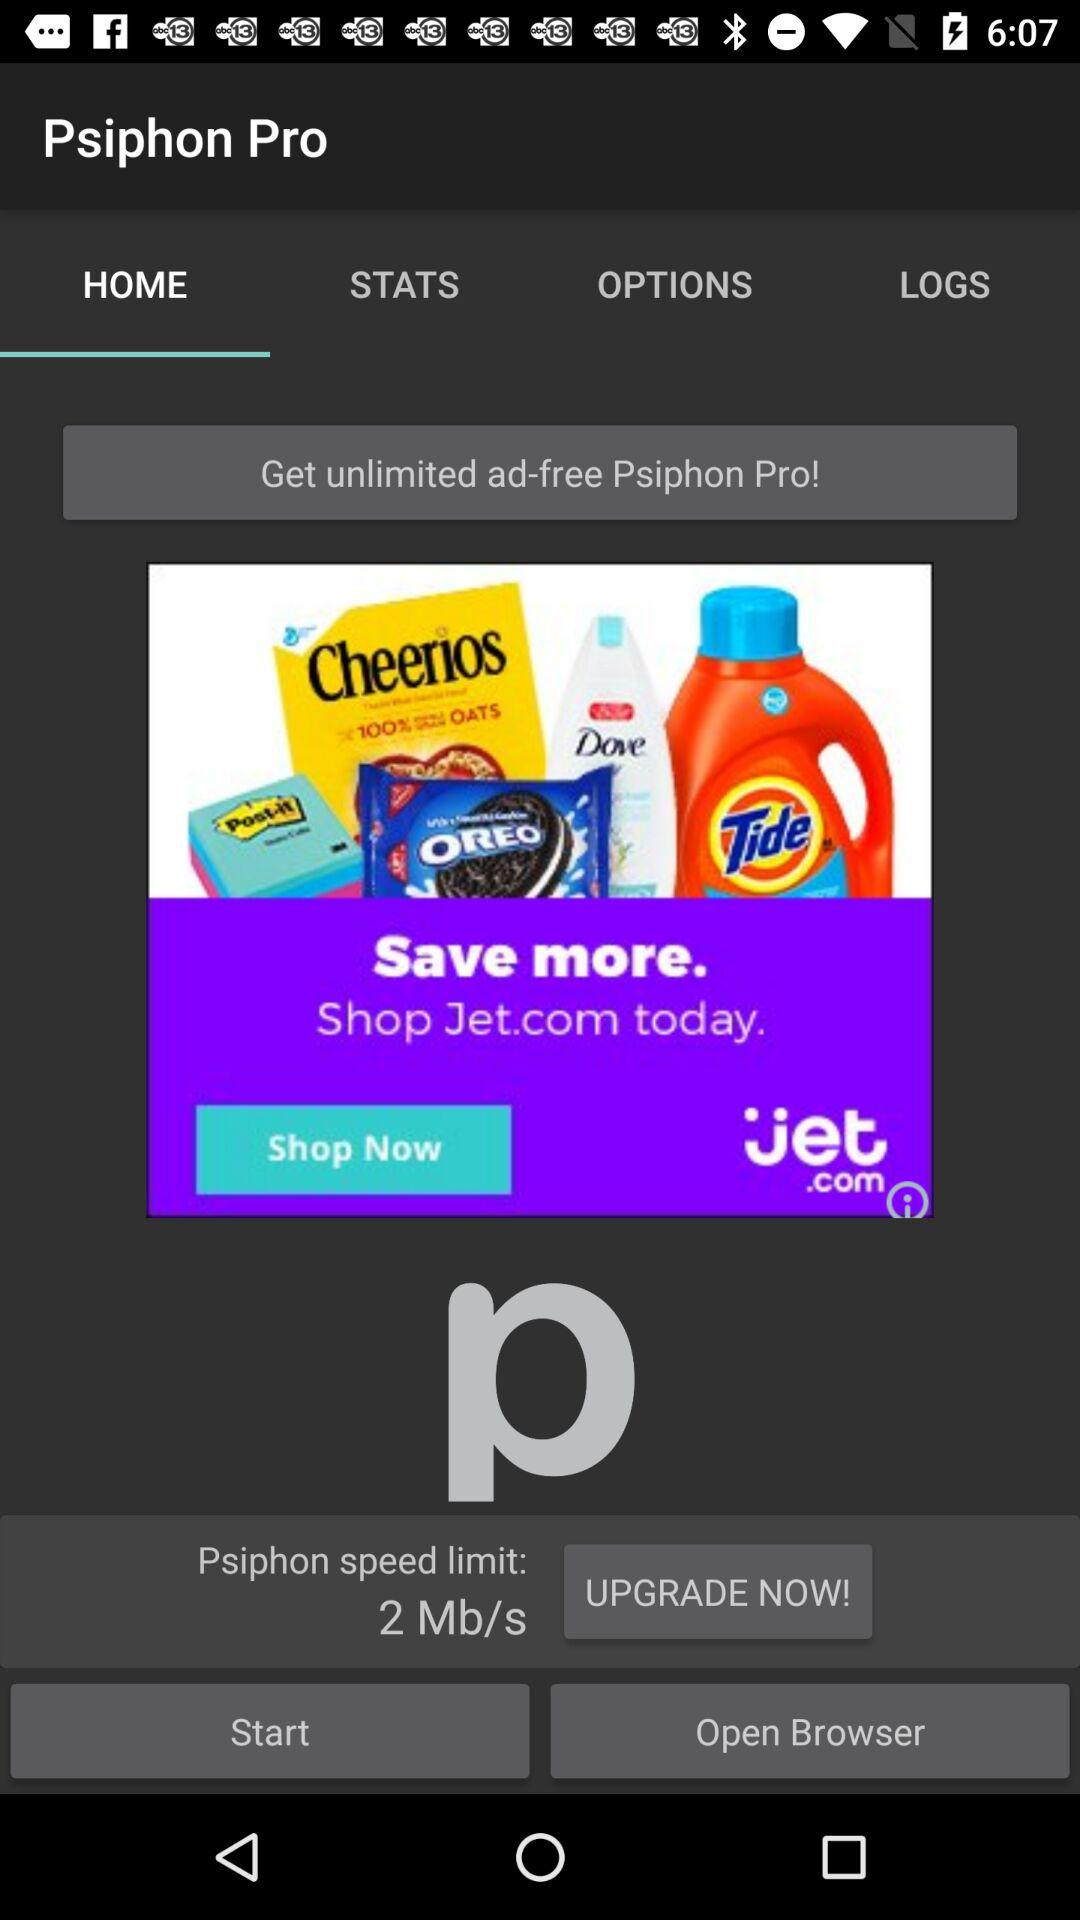Which tab is selected? The selected tab is "HOME". 